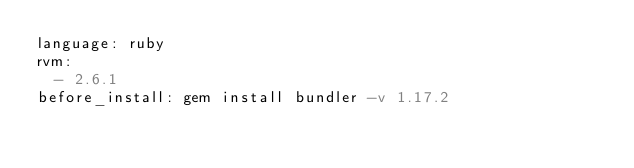Convert code to text. <code><loc_0><loc_0><loc_500><loc_500><_YAML_>language: ruby
rvm:
  - 2.6.1
before_install: gem install bundler -v 1.17.2
</code> 